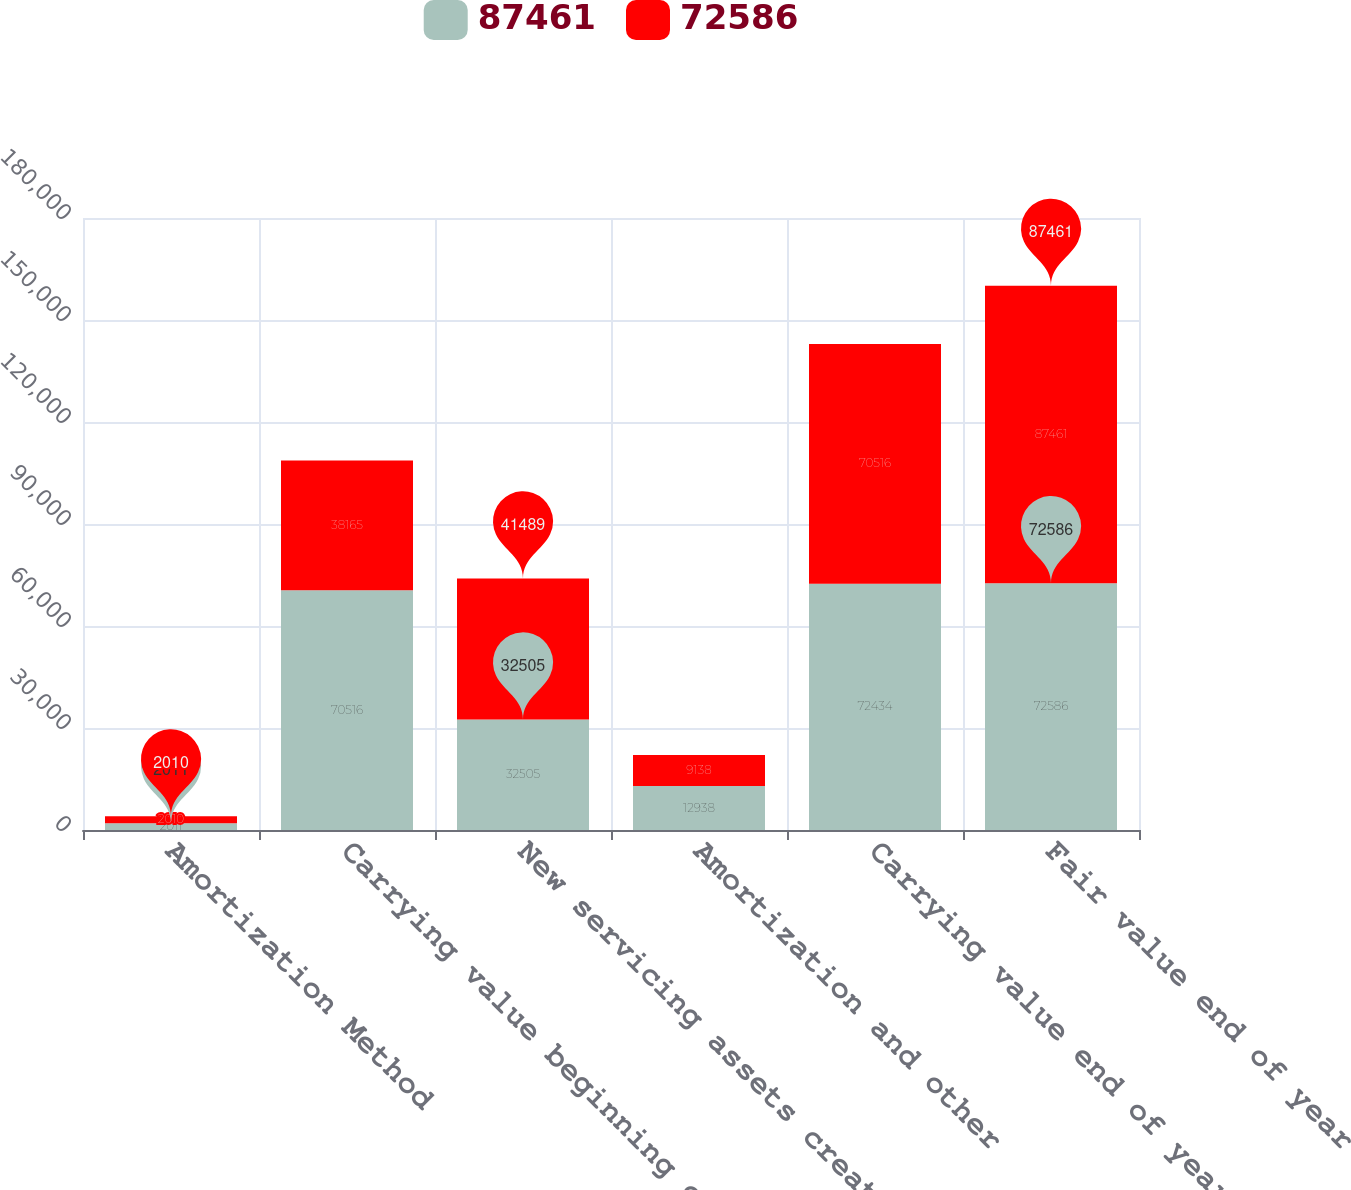Convert chart to OTSL. <chart><loc_0><loc_0><loc_500><loc_500><stacked_bar_chart><ecel><fcel>Amortization Method<fcel>Carrying value beginning of<fcel>New servicing assets created<fcel>Amortization and other<fcel>Carrying value end of year<fcel>Fair value end of year<nl><fcel>87461<fcel>2011<fcel>70516<fcel>32505<fcel>12938<fcel>72434<fcel>72586<nl><fcel>72586<fcel>2010<fcel>38165<fcel>41489<fcel>9138<fcel>70516<fcel>87461<nl></chart> 